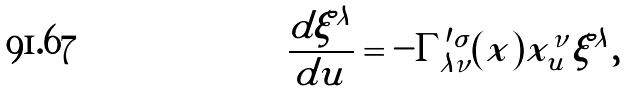Convert formula to latex. <formula><loc_0><loc_0><loc_500><loc_500>\frac { d \xi ^ { \lambda } } { d u } = - \Gamma ^ { \prime \sigma } _ { \lambda \nu } ( x ) x _ { u } ^ { \nu } \xi ^ { \lambda } ,</formula> 